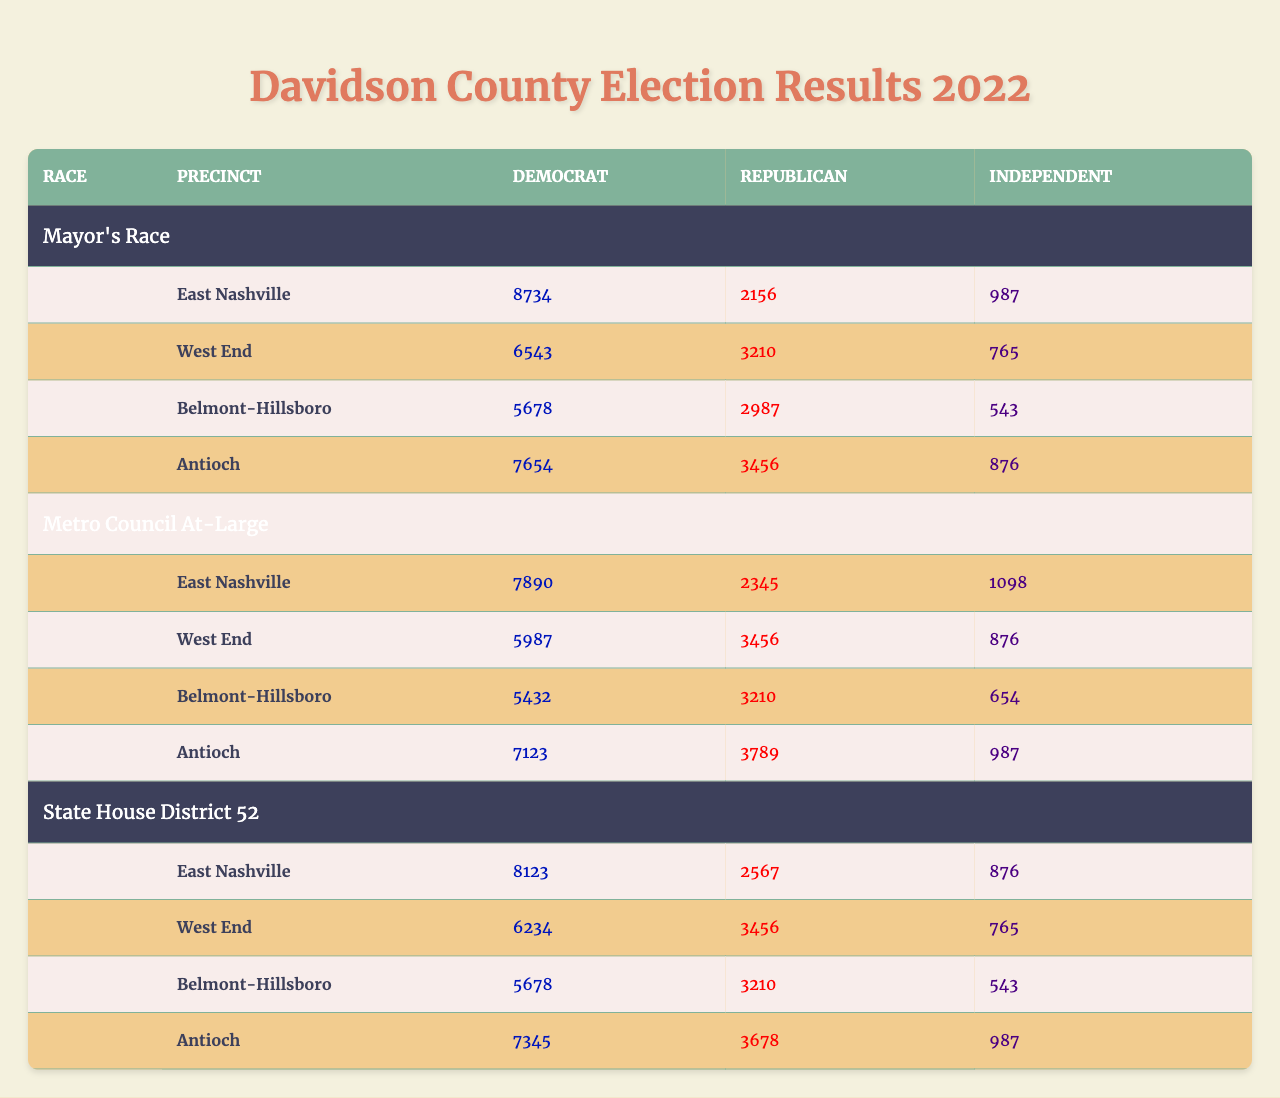What were the total votes for Democrats in the Mayor's Race in Antioch? The table shows that in Antioch, the number of votes for Democrats in the Mayor's Race is 7654.
Answer: 7654 Which precinct had the highest Republican votes in the Metro Council At-Large race? The table shows the Republican vote counts for each precinct in the Metro Council At-Large race. West End has 3456 votes, and Antioch has 3789 votes, which is the highest.
Answer: Antioch What is the total number of Independent votes across all precincts in the State House District 52 race? The Independent votes for the four precincts are: 876 (East Nashville) + 765 (West End) + 543 (Belmont-Hillsboro) + 987 (Antioch) = 3171.
Answer: 3171 Did East Nashville have more total Democrat votes in the Metro Council At-Large race compared to the State House District 52 race? In the Metro Council At-Large race, East Nashville had 7890 Democrat votes, while in the State House District 52 race, it had 8123. Thus, East Nashville had more votes in the State House District 52 race.
Answer: Yes What is the percentage of Independent votes in the Belmont-Hillsboro precinct for the Mayor's Race? Belmont-Hillsboro has 543 Independent votes out of a total of (5678 + 2987 + 543) = 9208 votes. The percentage of Independent votes is (543 / 9208) * 100 ≈ 5.9%.
Answer: Approximately 5.9% In which precinct is the difference between Democrat and Republican votes the greatest in the Mayor's Race? The differences in votes for each precinct are: East Nashville (8734 - 2156 = 6578), West End (6543 - 3210 = 3333), Belmont-Hillsboro (5678 - 2987 = 2681), Antioch (7654 - 3456 = 4198). East Nashville has the greatest difference of 6578 votes.
Answer: East Nashville Which precinct in the Metro Council At-Large race had the lowest Independent vote count, and what was that number? The Independent votes for each precinct are: East Nashville (1098), West End (876), Belmont-Hillsboro (654), and Antioch (987). Belmont-Hillsboro has the lowest count at 654 Independent votes.
Answer: Belmont-Hillsboro, 654 How many more Democrat votes did Antioch receive in the Mayor's Race compared to West End? Antioch received 7654 Democrat votes and West End received 6543 Democrat votes. The difference is 7654 - 6543 = 1111.
Answer: 1111 What was the total number of votes cast for all candidates in the State House District 52 race in East Nashville? In East Nashville, the total votes are: 8123 (Democrat) + 2567 (Republican) + 876 (Independent) = 11566 votes.
Answer: 11566 Is the total number of votes for Republicans in Belmont-Hillsboro higher than that in West End for the State House District 52 race? Belmont-Hillsboro received 3210 Republican votes and West End received 3456. 3210 is less than 3456, so the statement is false.
Answer: No 